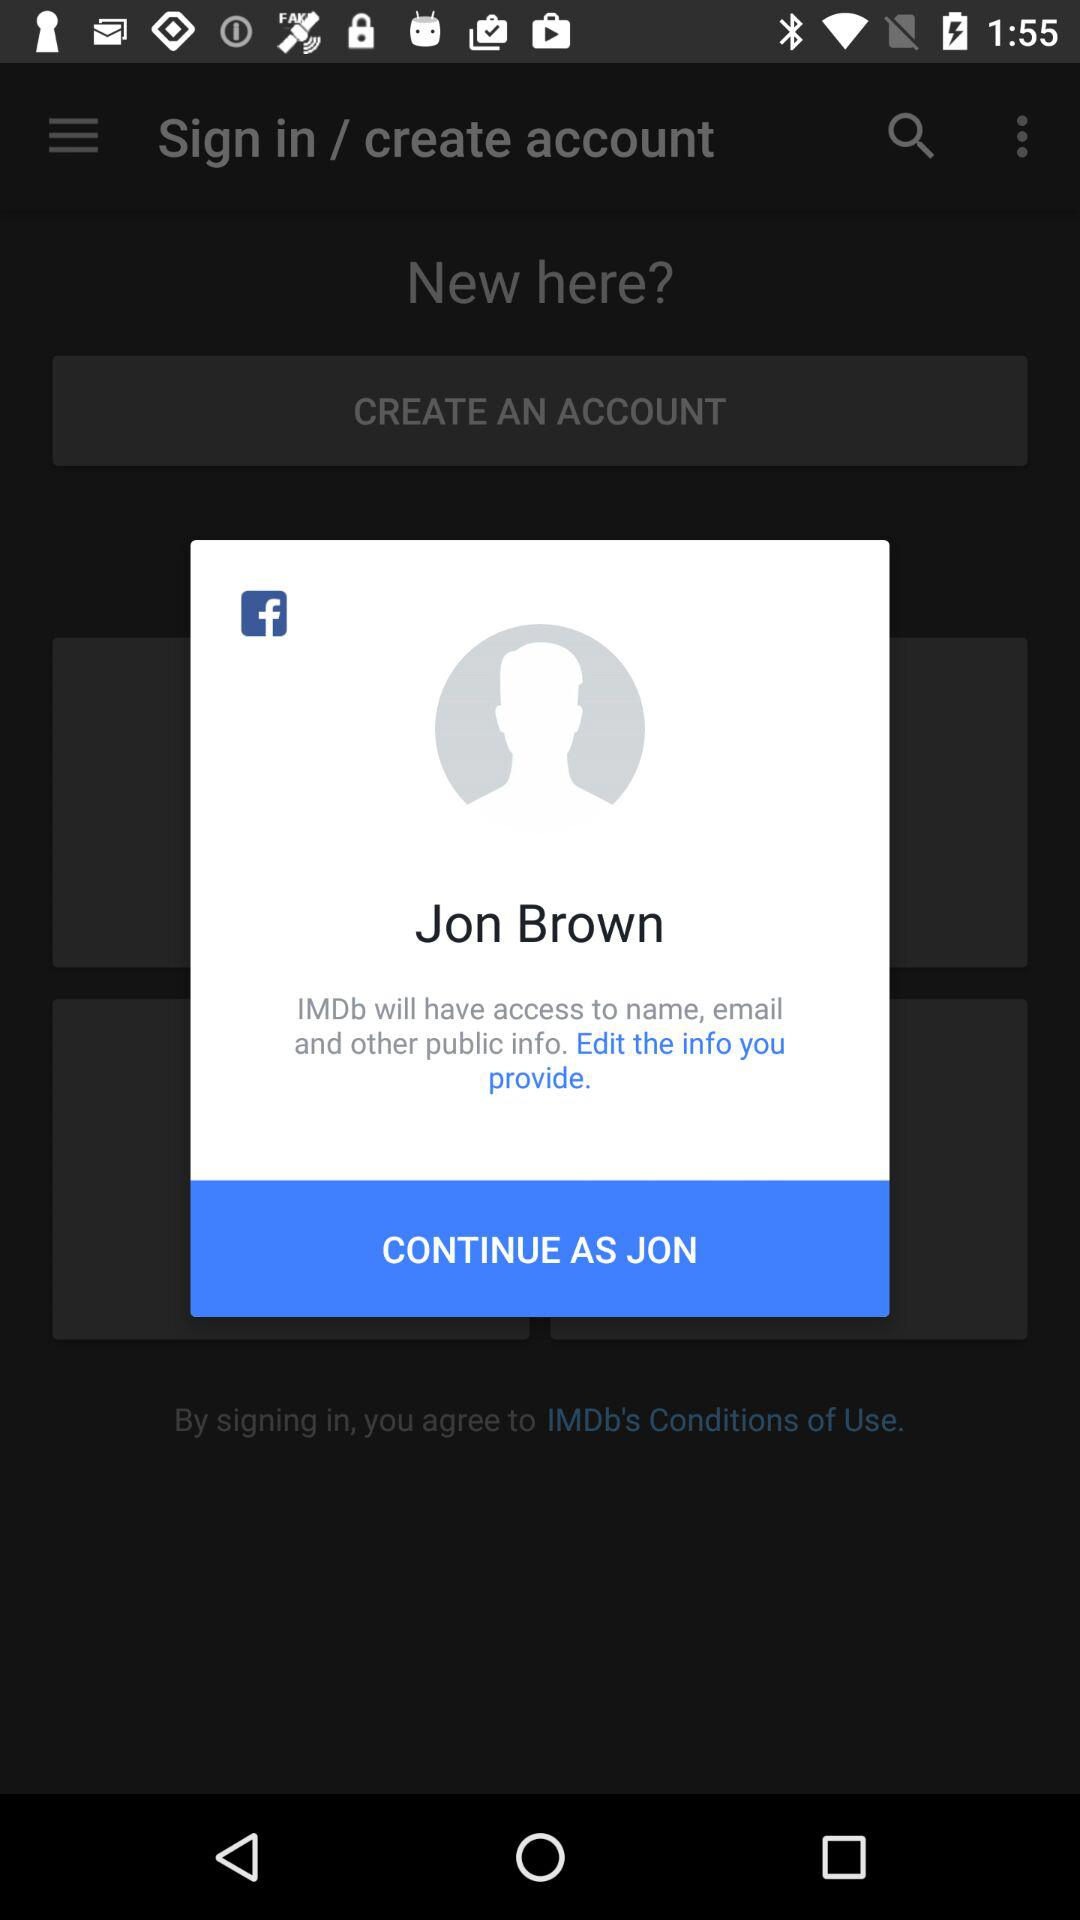What application will have access to names, email addresses and other public information? The application is "IMDb". 